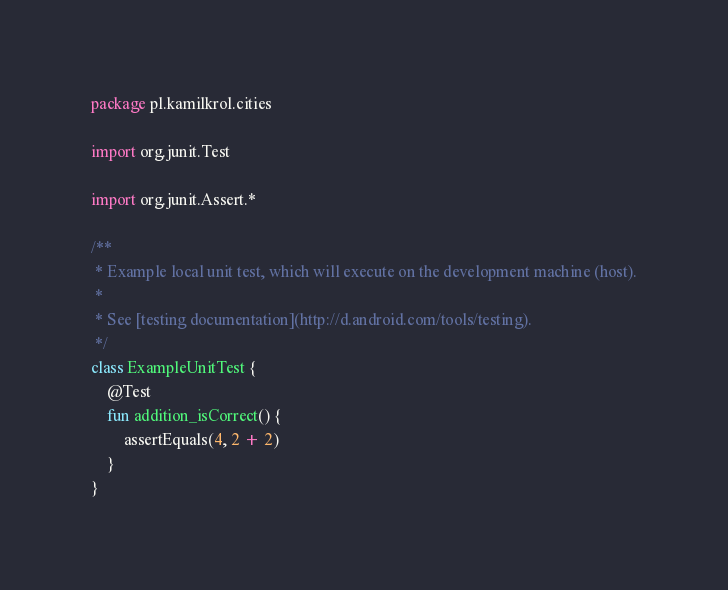Convert code to text. <code><loc_0><loc_0><loc_500><loc_500><_Kotlin_>package pl.kamilkrol.cities

import org.junit.Test

import org.junit.Assert.*

/**
 * Example local unit test, which will execute on the development machine (host).
 *
 * See [testing documentation](http://d.android.com/tools/testing).
 */
class ExampleUnitTest {
    @Test
    fun addition_isCorrect() {
        assertEquals(4, 2 + 2)
    }
}
</code> 